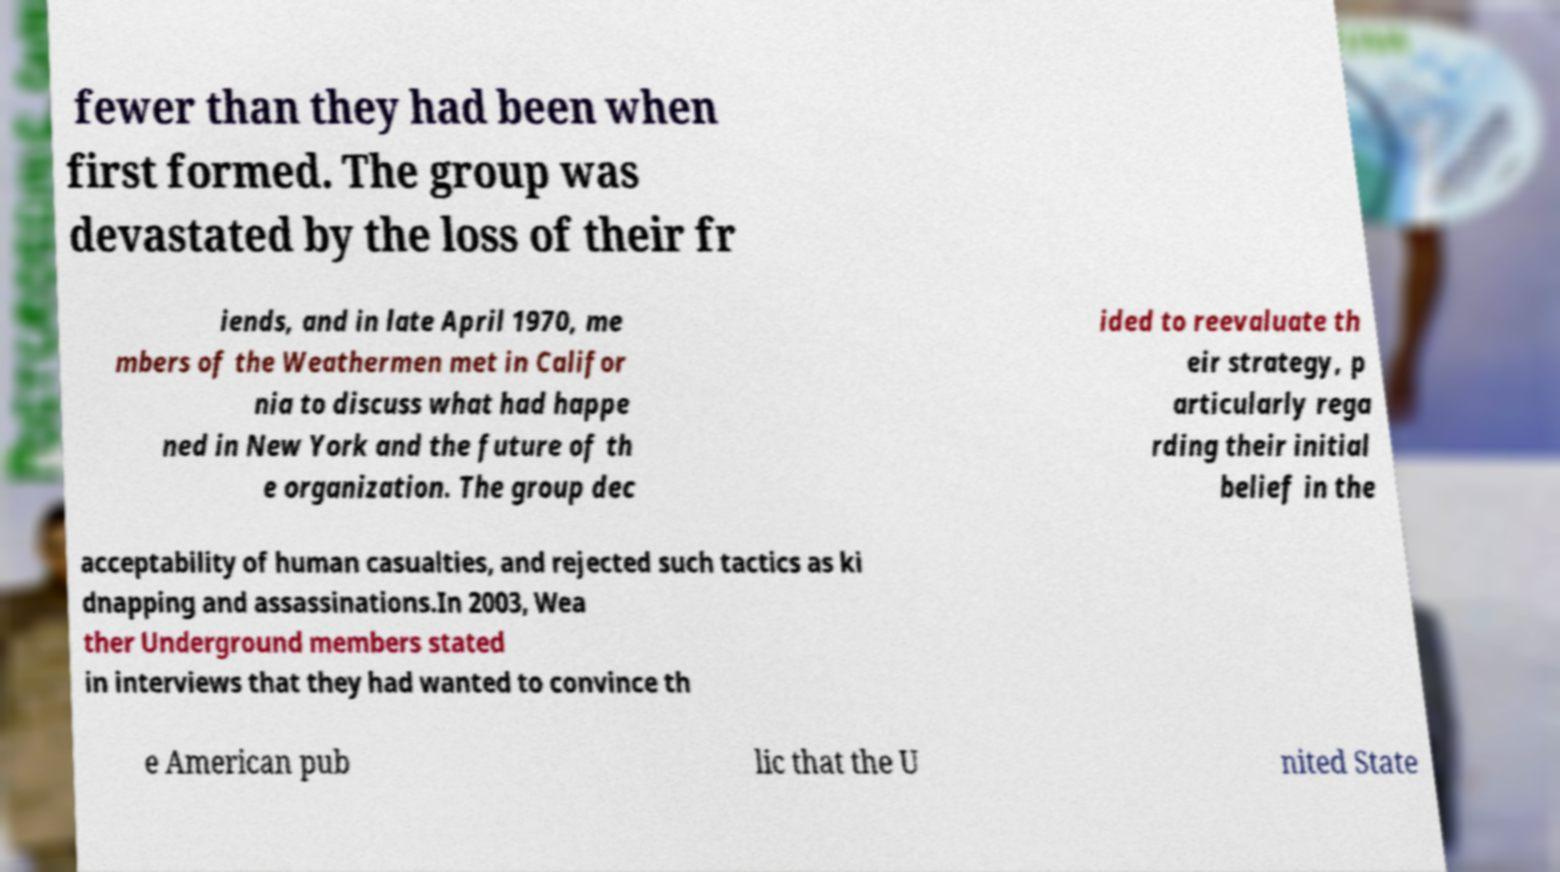I need the written content from this picture converted into text. Can you do that? fewer than they had been when first formed. The group was devastated by the loss of their fr iends, and in late April 1970, me mbers of the Weathermen met in Califor nia to discuss what had happe ned in New York and the future of th e organization. The group dec ided to reevaluate th eir strategy, p articularly rega rding their initial belief in the acceptability of human casualties, and rejected such tactics as ki dnapping and assassinations.In 2003, Wea ther Underground members stated in interviews that they had wanted to convince th e American pub lic that the U nited State 